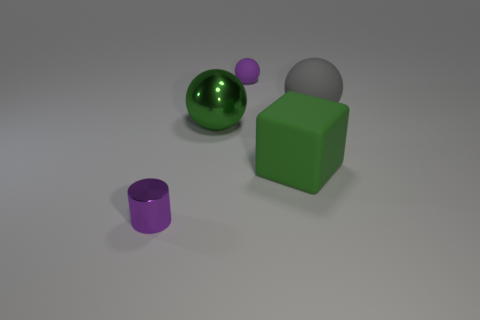Add 4 large green balls. How many objects exist? 9 Subtract all cubes. How many objects are left? 4 Add 5 yellow metallic cubes. How many yellow metallic cubes exist? 5 Subtract 0 cyan cylinders. How many objects are left? 5 Subtract all large gray things. Subtract all blocks. How many objects are left? 3 Add 5 gray rubber balls. How many gray rubber balls are left? 6 